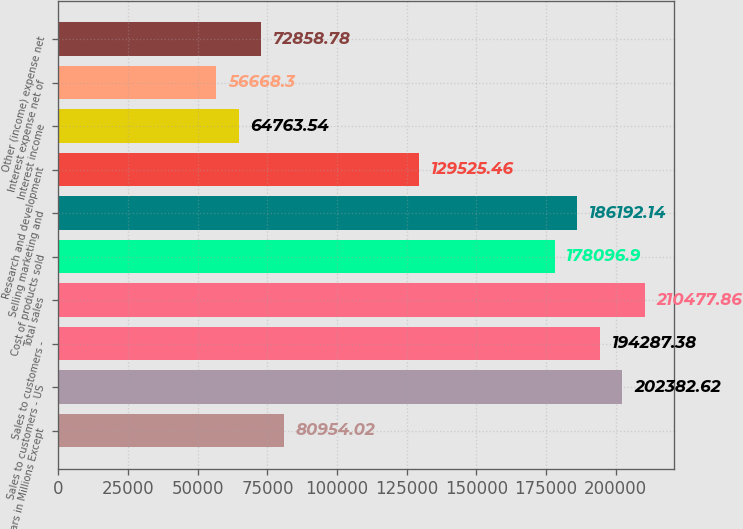<chart> <loc_0><loc_0><loc_500><loc_500><bar_chart><fcel>(Dollars in Millions Except<fcel>Sales to customers - US<fcel>Sales to customers -<fcel>Total sales<fcel>Cost of products sold<fcel>Selling marketing and<fcel>Research and development<fcel>Interest income<fcel>Interest expense net of<fcel>Other (income) expense net<nl><fcel>80954<fcel>202383<fcel>194287<fcel>210478<fcel>178097<fcel>186192<fcel>129525<fcel>64763.5<fcel>56668.3<fcel>72858.8<nl></chart> 